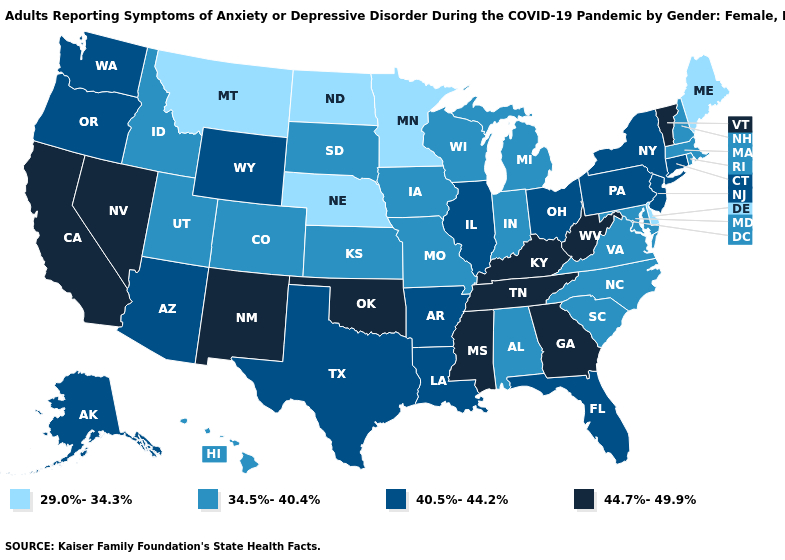How many symbols are there in the legend?
Keep it brief. 4. What is the value of Missouri?
Give a very brief answer. 34.5%-40.4%. Name the states that have a value in the range 44.7%-49.9%?
Give a very brief answer. California, Georgia, Kentucky, Mississippi, Nevada, New Mexico, Oklahoma, Tennessee, Vermont, West Virginia. What is the lowest value in the USA?
Quick response, please. 29.0%-34.3%. Does Arkansas have the same value as North Dakota?
Concise answer only. No. Does Michigan have the highest value in the USA?
Give a very brief answer. No. What is the value of Massachusetts?
Quick response, please. 34.5%-40.4%. Which states hav the highest value in the West?
Write a very short answer. California, Nevada, New Mexico. Name the states that have a value in the range 44.7%-49.9%?
Answer briefly. California, Georgia, Kentucky, Mississippi, Nevada, New Mexico, Oklahoma, Tennessee, Vermont, West Virginia. What is the value of Connecticut?
Short answer required. 40.5%-44.2%. Which states have the lowest value in the USA?
Quick response, please. Delaware, Maine, Minnesota, Montana, Nebraska, North Dakota. Does Delaware have the same value as Tennessee?
Give a very brief answer. No. Name the states that have a value in the range 40.5%-44.2%?
Concise answer only. Alaska, Arizona, Arkansas, Connecticut, Florida, Illinois, Louisiana, New Jersey, New York, Ohio, Oregon, Pennsylvania, Texas, Washington, Wyoming. What is the value of Iowa?
Be succinct. 34.5%-40.4%. 